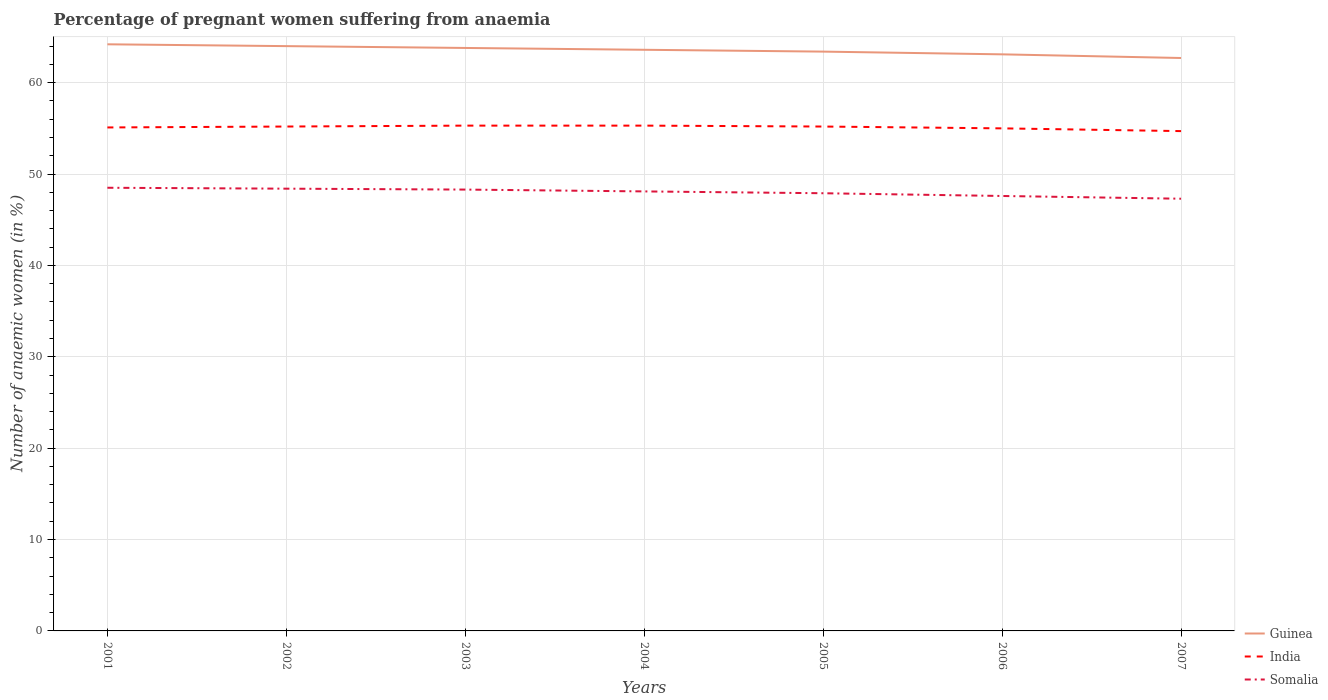How many different coloured lines are there?
Your answer should be compact. 3. Is the number of lines equal to the number of legend labels?
Keep it short and to the point. Yes. Across all years, what is the maximum number of anaemic women in Guinea?
Ensure brevity in your answer.  62.7. In which year was the number of anaemic women in Guinea maximum?
Your answer should be compact. 2007. What is the total number of anaemic women in Somalia in the graph?
Provide a short and direct response. 0.6. How many lines are there?
Provide a succinct answer. 3. How many years are there in the graph?
Provide a succinct answer. 7. What is the difference between two consecutive major ticks on the Y-axis?
Provide a short and direct response. 10. Are the values on the major ticks of Y-axis written in scientific E-notation?
Give a very brief answer. No. Where does the legend appear in the graph?
Offer a terse response. Bottom right. How many legend labels are there?
Your answer should be very brief. 3. What is the title of the graph?
Give a very brief answer. Percentage of pregnant women suffering from anaemia. Does "Philippines" appear as one of the legend labels in the graph?
Offer a very short reply. No. What is the label or title of the X-axis?
Your answer should be compact. Years. What is the label or title of the Y-axis?
Ensure brevity in your answer.  Number of anaemic women (in %). What is the Number of anaemic women (in %) of Guinea in 2001?
Give a very brief answer. 64.2. What is the Number of anaemic women (in %) in India in 2001?
Keep it short and to the point. 55.1. What is the Number of anaemic women (in %) of Somalia in 2001?
Keep it short and to the point. 48.5. What is the Number of anaemic women (in %) in India in 2002?
Your answer should be very brief. 55.2. What is the Number of anaemic women (in %) in Somalia in 2002?
Provide a short and direct response. 48.4. What is the Number of anaemic women (in %) in Guinea in 2003?
Your answer should be very brief. 63.8. What is the Number of anaemic women (in %) in India in 2003?
Ensure brevity in your answer.  55.3. What is the Number of anaemic women (in %) of Somalia in 2003?
Your answer should be very brief. 48.3. What is the Number of anaemic women (in %) in Guinea in 2004?
Ensure brevity in your answer.  63.6. What is the Number of anaemic women (in %) of India in 2004?
Make the answer very short. 55.3. What is the Number of anaemic women (in %) of Somalia in 2004?
Provide a short and direct response. 48.1. What is the Number of anaemic women (in %) of Guinea in 2005?
Provide a succinct answer. 63.4. What is the Number of anaemic women (in %) in India in 2005?
Provide a succinct answer. 55.2. What is the Number of anaemic women (in %) in Somalia in 2005?
Ensure brevity in your answer.  47.9. What is the Number of anaemic women (in %) of Guinea in 2006?
Ensure brevity in your answer.  63.1. What is the Number of anaemic women (in %) of Somalia in 2006?
Make the answer very short. 47.6. What is the Number of anaemic women (in %) in Guinea in 2007?
Offer a terse response. 62.7. What is the Number of anaemic women (in %) in India in 2007?
Make the answer very short. 54.7. What is the Number of anaemic women (in %) in Somalia in 2007?
Make the answer very short. 47.3. Across all years, what is the maximum Number of anaemic women (in %) of Guinea?
Offer a very short reply. 64.2. Across all years, what is the maximum Number of anaemic women (in %) of India?
Offer a terse response. 55.3. Across all years, what is the maximum Number of anaemic women (in %) in Somalia?
Offer a very short reply. 48.5. Across all years, what is the minimum Number of anaemic women (in %) in Guinea?
Make the answer very short. 62.7. Across all years, what is the minimum Number of anaemic women (in %) of India?
Provide a succinct answer. 54.7. Across all years, what is the minimum Number of anaemic women (in %) in Somalia?
Keep it short and to the point. 47.3. What is the total Number of anaemic women (in %) in Guinea in the graph?
Your response must be concise. 444.8. What is the total Number of anaemic women (in %) in India in the graph?
Offer a terse response. 385.8. What is the total Number of anaemic women (in %) of Somalia in the graph?
Give a very brief answer. 336.1. What is the difference between the Number of anaemic women (in %) in Guinea in 2001 and that in 2002?
Keep it short and to the point. 0.2. What is the difference between the Number of anaemic women (in %) of India in 2001 and that in 2002?
Your response must be concise. -0.1. What is the difference between the Number of anaemic women (in %) of India in 2001 and that in 2003?
Provide a succinct answer. -0.2. What is the difference between the Number of anaemic women (in %) in Somalia in 2001 and that in 2003?
Make the answer very short. 0.2. What is the difference between the Number of anaemic women (in %) of Guinea in 2001 and that in 2004?
Give a very brief answer. 0.6. What is the difference between the Number of anaemic women (in %) in India in 2001 and that in 2004?
Your answer should be compact. -0.2. What is the difference between the Number of anaemic women (in %) in Somalia in 2001 and that in 2004?
Offer a terse response. 0.4. What is the difference between the Number of anaemic women (in %) of Guinea in 2001 and that in 2006?
Your response must be concise. 1.1. What is the difference between the Number of anaemic women (in %) of Somalia in 2001 and that in 2006?
Make the answer very short. 0.9. What is the difference between the Number of anaemic women (in %) of Somalia in 2001 and that in 2007?
Your answer should be very brief. 1.2. What is the difference between the Number of anaemic women (in %) of India in 2002 and that in 2003?
Provide a short and direct response. -0.1. What is the difference between the Number of anaemic women (in %) in Guinea in 2002 and that in 2004?
Provide a short and direct response. 0.4. What is the difference between the Number of anaemic women (in %) in Somalia in 2002 and that in 2004?
Your answer should be very brief. 0.3. What is the difference between the Number of anaemic women (in %) in India in 2002 and that in 2005?
Your answer should be compact. 0. What is the difference between the Number of anaemic women (in %) in Somalia in 2002 and that in 2006?
Give a very brief answer. 0.8. What is the difference between the Number of anaemic women (in %) of Guinea in 2002 and that in 2007?
Your answer should be very brief. 1.3. What is the difference between the Number of anaemic women (in %) in India in 2002 and that in 2007?
Make the answer very short. 0.5. What is the difference between the Number of anaemic women (in %) in Somalia in 2002 and that in 2007?
Provide a short and direct response. 1.1. What is the difference between the Number of anaemic women (in %) of Guinea in 2003 and that in 2004?
Make the answer very short. 0.2. What is the difference between the Number of anaemic women (in %) of Guinea in 2003 and that in 2005?
Provide a short and direct response. 0.4. What is the difference between the Number of anaemic women (in %) in Somalia in 2003 and that in 2005?
Provide a short and direct response. 0.4. What is the difference between the Number of anaemic women (in %) in Somalia in 2003 and that in 2006?
Offer a terse response. 0.7. What is the difference between the Number of anaemic women (in %) in Guinea in 2003 and that in 2007?
Your answer should be very brief. 1.1. What is the difference between the Number of anaemic women (in %) of Somalia in 2003 and that in 2007?
Your response must be concise. 1. What is the difference between the Number of anaemic women (in %) in Guinea in 2004 and that in 2005?
Ensure brevity in your answer.  0.2. What is the difference between the Number of anaemic women (in %) in India in 2004 and that in 2006?
Give a very brief answer. 0.3. What is the difference between the Number of anaemic women (in %) of Guinea in 2004 and that in 2007?
Your answer should be very brief. 0.9. What is the difference between the Number of anaemic women (in %) in Guinea in 2005 and that in 2007?
Your response must be concise. 0.7. What is the difference between the Number of anaemic women (in %) of Somalia in 2005 and that in 2007?
Your answer should be very brief. 0.6. What is the difference between the Number of anaemic women (in %) of India in 2001 and the Number of anaemic women (in %) of Somalia in 2002?
Your answer should be very brief. 6.7. What is the difference between the Number of anaemic women (in %) in India in 2001 and the Number of anaemic women (in %) in Somalia in 2003?
Give a very brief answer. 6.8. What is the difference between the Number of anaemic women (in %) of Guinea in 2001 and the Number of anaemic women (in %) of India in 2004?
Offer a very short reply. 8.9. What is the difference between the Number of anaemic women (in %) of Guinea in 2001 and the Number of anaemic women (in %) of Somalia in 2004?
Offer a very short reply. 16.1. What is the difference between the Number of anaemic women (in %) of India in 2001 and the Number of anaemic women (in %) of Somalia in 2005?
Ensure brevity in your answer.  7.2. What is the difference between the Number of anaemic women (in %) of Guinea in 2001 and the Number of anaemic women (in %) of Somalia in 2006?
Your answer should be very brief. 16.6. What is the difference between the Number of anaemic women (in %) in India in 2001 and the Number of anaemic women (in %) in Somalia in 2006?
Make the answer very short. 7.5. What is the difference between the Number of anaemic women (in %) in Guinea in 2001 and the Number of anaemic women (in %) in India in 2007?
Provide a short and direct response. 9.5. What is the difference between the Number of anaemic women (in %) in Guinea in 2001 and the Number of anaemic women (in %) in Somalia in 2007?
Provide a short and direct response. 16.9. What is the difference between the Number of anaemic women (in %) of India in 2001 and the Number of anaemic women (in %) of Somalia in 2007?
Give a very brief answer. 7.8. What is the difference between the Number of anaemic women (in %) of Guinea in 2002 and the Number of anaemic women (in %) of Somalia in 2003?
Provide a short and direct response. 15.7. What is the difference between the Number of anaemic women (in %) in India in 2002 and the Number of anaemic women (in %) in Somalia in 2003?
Make the answer very short. 6.9. What is the difference between the Number of anaemic women (in %) in Guinea in 2002 and the Number of anaemic women (in %) in India in 2004?
Keep it short and to the point. 8.7. What is the difference between the Number of anaemic women (in %) of Guinea in 2002 and the Number of anaemic women (in %) of Somalia in 2004?
Your answer should be very brief. 15.9. What is the difference between the Number of anaemic women (in %) in India in 2002 and the Number of anaemic women (in %) in Somalia in 2004?
Keep it short and to the point. 7.1. What is the difference between the Number of anaemic women (in %) of Guinea in 2002 and the Number of anaemic women (in %) of India in 2005?
Provide a short and direct response. 8.8. What is the difference between the Number of anaemic women (in %) in Guinea in 2002 and the Number of anaemic women (in %) in Somalia in 2005?
Your answer should be compact. 16.1. What is the difference between the Number of anaemic women (in %) of India in 2002 and the Number of anaemic women (in %) of Somalia in 2006?
Offer a terse response. 7.6. What is the difference between the Number of anaemic women (in %) in Guinea in 2003 and the Number of anaemic women (in %) in Somalia in 2004?
Offer a very short reply. 15.7. What is the difference between the Number of anaemic women (in %) of India in 2003 and the Number of anaemic women (in %) of Somalia in 2005?
Your answer should be compact. 7.4. What is the difference between the Number of anaemic women (in %) of Guinea in 2003 and the Number of anaemic women (in %) of Somalia in 2006?
Keep it short and to the point. 16.2. What is the difference between the Number of anaemic women (in %) in India in 2003 and the Number of anaemic women (in %) in Somalia in 2006?
Offer a very short reply. 7.7. What is the difference between the Number of anaemic women (in %) in Guinea in 2003 and the Number of anaemic women (in %) in India in 2007?
Provide a succinct answer. 9.1. What is the difference between the Number of anaemic women (in %) in Guinea in 2003 and the Number of anaemic women (in %) in Somalia in 2007?
Keep it short and to the point. 16.5. What is the difference between the Number of anaemic women (in %) of India in 2003 and the Number of anaemic women (in %) of Somalia in 2007?
Ensure brevity in your answer.  8. What is the difference between the Number of anaemic women (in %) in Guinea in 2004 and the Number of anaemic women (in %) in India in 2005?
Your answer should be very brief. 8.4. What is the difference between the Number of anaemic women (in %) of India in 2004 and the Number of anaemic women (in %) of Somalia in 2005?
Your answer should be very brief. 7.4. What is the difference between the Number of anaemic women (in %) of Guinea in 2005 and the Number of anaemic women (in %) of India in 2006?
Offer a very short reply. 8.4. What is the difference between the Number of anaemic women (in %) in India in 2005 and the Number of anaemic women (in %) in Somalia in 2006?
Ensure brevity in your answer.  7.6. What is the difference between the Number of anaemic women (in %) of Guinea in 2005 and the Number of anaemic women (in %) of India in 2007?
Offer a terse response. 8.7. What is the difference between the Number of anaemic women (in %) of Guinea in 2005 and the Number of anaemic women (in %) of Somalia in 2007?
Your answer should be very brief. 16.1. What is the difference between the Number of anaemic women (in %) of Guinea in 2006 and the Number of anaemic women (in %) of India in 2007?
Give a very brief answer. 8.4. What is the average Number of anaemic women (in %) in Guinea per year?
Make the answer very short. 63.54. What is the average Number of anaemic women (in %) of India per year?
Provide a succinct answer. 55.11. What is the average Number of anaemic women (in %) in Somalia per year?
Offer a terse response. 48.01. In the year 2001, what is the difference between the Number of anaemic women (in %) of Guinea and Number of anaemic women (in %) of Somalia?
Keep it short and to the point. 15.7. In the year 2002, what is the difference between the Number of anaemic women (in %) in Guinea and Number of anaemic women (in %) in India?
Your answer should be compact. 8.8. In the year 2002, what is the difference between the Number of anaemic women (in %) in Guinea and Number of anaemic women (in %) in Somalia?
Provide a succinct answer. 15.6. In the year 2003, what is the difference between the Number of anaemic women (in %) of Guinea and Number of anaemic women (in %) of India?
Give a very brief answer. 8.5. In the year 2003, what is the difference between the Number of anaemic women (in %) of Guinea and Number of anaemic women (in %) of Somalia?
Offer a terse response. 15.5. In the year 2004, what is the difference between the Number of anaemic women (in %) of India and Number of anaemic women (in %) of Somalia?
Your answer should be very brief. 7.2. In the year 2005, what is the difference between the Number of anaemic women (in %) in Guinea and Number of anaemic women (in %) in India?
Ensure brevity in your answer.  8.2. In the year 2005, what is the difference between the Number of anaemic women (in %) in Guinea and Number of anaemic women (in %) in Somalia?
Provide a short and direct response. 15.5. In the year 2007, what is the difference between the Number of anaemic women (in %) of Guinea and Number of anaemic women (in %) of India?
Your response must be concise. 8. In the year 2007, what is the difference between the Number of anaemic women (in %) in Guinea and Number of anaemic women (in %) in Somalia?
Your response must be concise. 15.4. What is the ratio of the Number of anaemic women (in %) of Guinea in 2001 to that in 2003?
Provide a short and direct response. 1.01. What is the ratio of the Number of anaemic women (in %) in India in 2001 to that in 2003?
Offer a very short reply. 1. What is the ratio of the Number of anaemic women (in %) of Somalia in 2001 to that in 2003?
Provide a short and direct response. 1. What is the ratio of the Number of anaemic women (in %) in Guinea in 2001 to that in 2004?
Your response must be concise. 1.01. What is the ratio of the Number of anaemic women (in %) in India in 2001 to that in 2004?
Give a very brief answer. 1. What is the ratio of the Number of anaemic women (in %) in Somalia in 2001 to that in 2004?
Your answer should be very brief. 1.01. What is the ratio of the Number of anaemic women (in %) in Guinea in 2001 to that in 2005?
Your response must be concise. 1.01. What is the ratio of the Number of anaemic women (in %) in Somalia in 2001 to that in 2005?
Your answer should be very brief. 1.01. What is the ratio of the Number of anaemic women (in %) in Guinea in 2001 to that in 2006?
Ensure brevity in your answer.  1.02. What is the ratio of the Number of anaemic women (in %) in India in 2001 to that in 2006?
Offer a very short reply. 1. What is the ratio of the Number of anaemic women (in %) of Somalia in 2001 to that in 2006?
Your response must be concise. 1.02. What is the ratio of the Number of anaemic women (in %) in Guinea in 2001 to that in 2007?
Keep it short and to the point. 1.02. What is the ratio of the Number of anaemic women (in %) in India in 2001 to that in 2007?
Offer a terse response. 1.01. What is the ratio of the Number of anaemic women (in %) of Somalia in 2001 to that in 2007?
Give a very brief answer. 1.03. What is the ratio of the Number of anaemic women (in %) of India in 2002 to that in 2004?
Give a very brief answer. 1. What is the ratio of the Number of anaemic women (in %) of Guinea in 2002 to that in 2005?
Provide a short and direct response. 1.01. What is the ratio of the Number of anaemic women (in %) in India in 2002 to that in 2005?
Ensure brevity in your answer.  1. What is the ratio of the Number of anaemic women (in %) of Somalia in 2002 to that in 2005?
Provide a succinct answer. 1.01. What is the ratio of the Number of anaemic women (in %) in Guinea in 2002 to that in 2006?
Ensure brevity in your answer.  1.01. What is the ratio of the Number of anaemic women (in %) in India in 2002 to that in 2006?
Make the answer very short. 1. What is the ratio of the Number of anaemic women (in %) of Somalia in 2002 to that in 2006?
Offer a terse response. 1.02. What is the ratio of the Number of anaemic women (in %) in Guinea in 2002 to that in 2007?
Your response must be concise. 1.02. What is the ratio of the Number of anaemic women (in %) in India in 2002 to that in 2007?
Your answer should be very brief. 1.01. What is the ratio of the Number of anaemic women (in %) in Somalia in 2002 to that in 2007?
Your response must be concise. 1.02. What is the ratio of the Number of anaemic women (in %) in India in 2003 to that in 2004?
Your answer should be compact. 1. What is the ratio of the Number of anaemic women (in %) of Somalia in 2003 to that in 2004?
Give a very brief answer. 1. What is the ratio of the Number of anaemic women (in %) of Guinea in 2003 to that in 2005?
Keep it short and to the point. 1.01. What is the ratio of the Number of anaemic women (in %) of India in 2003 to that in 2005?
Give a very brief answer. 1. What is the ratio of the Number of anaemic women (in %) of Somalia in 2003 to that in 2005?
Provide a short and direct response. 1.01. What is the ratio of the Number of anaemic women (in %) of Guinea in 2003 to that in 2006?
Your answer should be compact. 1.01. What is the ratio of the Number of anaemic women (in %) of India in 2003 to that in 2006?
Keep it short and to the point. 1.01. What is the ratio of the Number of anaemic women (in %) of Somalia in 2003 to that in 2006?
Make the answer very short. 1.01. What is the ratio of the Number of anaemic women (in %) in Guinea in 2003 to that in 2007?
Offer a very short reply. 1.02. What is the ratio of the Number of anaemic women (in %) of Somalia in 2003 to that in 2007?
Give a very brief answer. 1.02. What is the ratio of the Number of anaemic women (in %) of Guinea in 2004 to that in 2005?
Provide a short and direct response. 1. What is the ratio of the Number of anaemic women (in %) in Somalia in 2004 to that in 2005?
Offer a very short reply. 1. What is the ratio of the Number of anaemic women (in %) of Guinea in 2004 to that in 2006?
Offer a very short reply. 1.01. What is the ratio of the Number of anaemic women (in %) in India in 2004 to that in 2006?
Provide a short and direct response. 1.01. What is the ratio of the Number of anaemic women (in %) of Somalia in 2004 to that in 2006?
Your answer should be very brief. 1.01. What is the ratio of the Number of anaemic women (in %) in Guinea in 2004 to that in 2007?
Make the answer very short. 1.01. What is the ratio of the Number of anaemic women (in %) in Somalia in 2004 to that in 2007?
Your answer should be very brief. 1.02. What is the ratio of the Number of anaemic women (in %) of Somalia in 2005 to that in 2006?
Provide a succinct answer. 1.01. What is the ratio of the Number of anaemic women (in %) in Guinea in 2005 to that in 2007?
Offer a very short reply. 1.01. What is the ratio of the Number of anaemic women (in %) in India in 2005 to that in 2007?
Offer a very short reply. 1.01. What is the ratio of the Number of anaemic women (in %) of Somalia in 2005 to that in 2007?
Ensure brevity in your answer.  1.01. What is the ratio of the Number of anaemic women (in %) in Guinea in 2006 to that in 2007?
Ensure brevity in your answer.  1.01. What is the ratio of the Number of anaemic women (in %) of India in 2006 to that in 2007?
Make the answer very short. 1.01. What is the difference between the highest and the second highest Number of anaemic women (in %) of Guinea?
Your answer should be compact. 0.2. What is the difference between the highest and the second highest Number of anaemic women (in %) of Somalia?
Your response must be concise. 0.1. What is the difference between the highest and the lowest Number of anaemic women (in %) of India?
Ensure brevity in your answer.  0.6. What is the difference between the highest and the lowest Number of anaemic women (in %) in Somalia?
Provide a short and direct response. 1.2. 